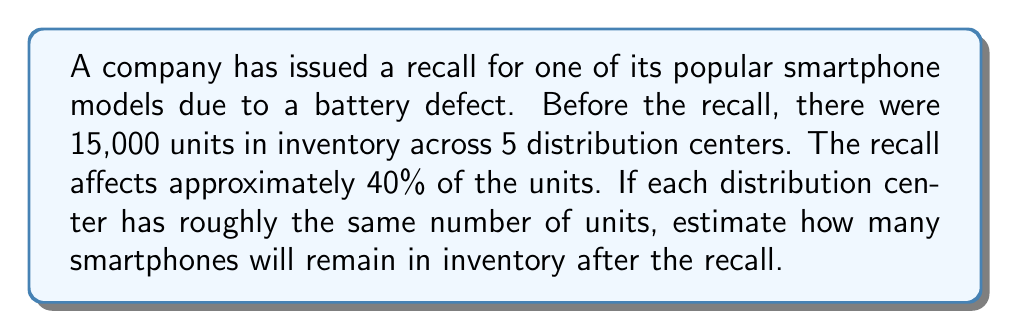Provide a solution to this math problem. Let's break this down step-by-step:

1. Calculate the total number of units affected by the recall:
   $$ \text{Affected units} = \text{Total units} \times \text{Percentage affected} $$
   $$ \text{Affected units} = 15,000 \times 40\% = 15,000 \times 0.40 = 6,000 \text{ units} $$

2. Calculate the remaining inventory after the recall:
   $$ \text{Remaining inventory} = \text{Total units} - \text{Affected units} $$
   $$ \text{Remaining inventory} = 15,000 - 6,000 = 9,000 \text{ units} $$

3. Since the question asks for an estimate and mentions that each distribution center has roughly the same number of units, we can assume an even distribution:
   $$ \text{Units per distribution center} = \frac{\text{Remaining inventory}}{\text{Number of distribution centers}} $$
   $$ \text{Units per distribution center} = \frac{9,000}{5} = 1,800 \text{ units} $$

Therefore, we can estimate that approximately 1,800 units will remain in each distribution center, for a total of 9,000 units across all 5 centers.
Answer: Approximately 9,000 smartphones will remain in inventory after the recall. 